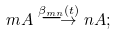Convert formula to latex. <formula><loc_0><loc_0><loc_500><loc_500>m A \stackrel { \beta _ { m n } ( t ) } { \longrightarrow } n A ;</formula> 